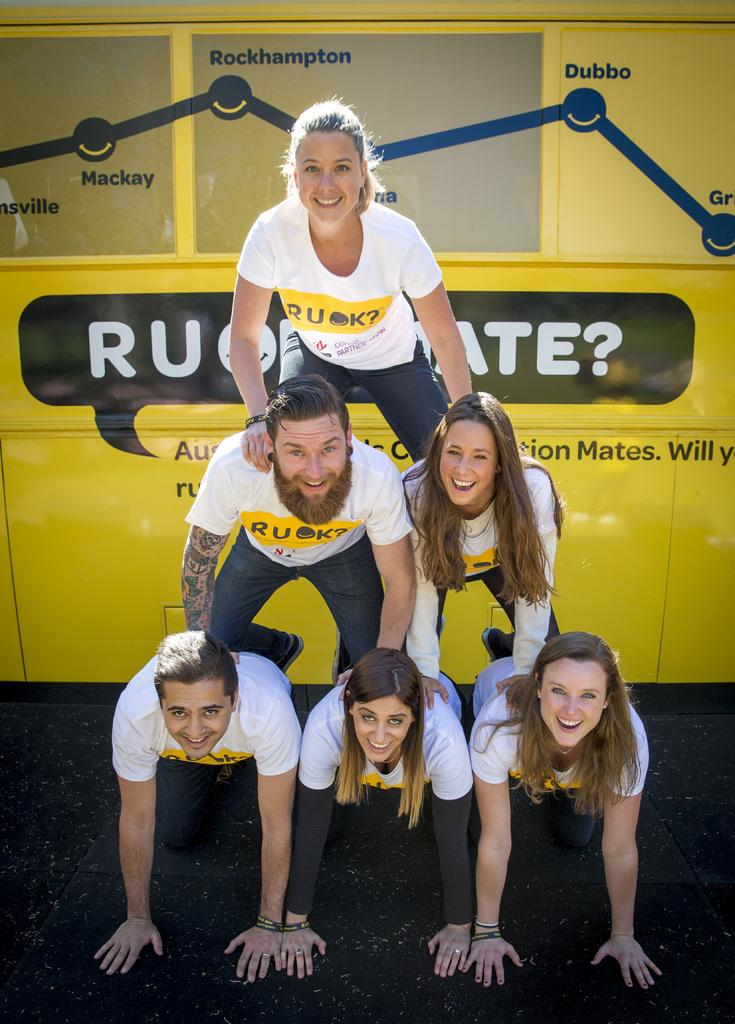<image>
Give a short and clear explanation of the subsequent image. Locations on a sign include Rockhampton, Mackay and Dubbo. 